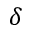<formula> <loc_0><loc_0><loc_500><loc_500>\delta</formula> 